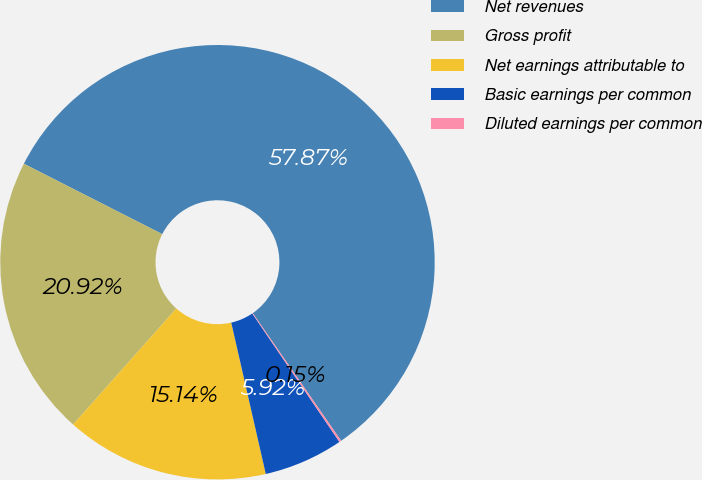Convert chart to OTSL. <chart><loc_0><loc_0><loc_500><loc_500><pie_chart><fcel>Net revenues<fcel>Gross profit<fcel>Net earnings attributable to<fcel>Basic earnings per common<fcel>Diluted earnings per common<nl><fcel>57.88%<fcel>20.92%<fcel>15.14%<fcel>5.92%<fcel>0.15%<nl></chart> 